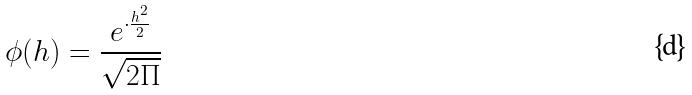<formula> <loc_0><loc_0><loc_500><loc_500>\phi ( h ) = \frac { e ^ { \cdot \frac { h ^ { 2 } } { 2 } } } { \sqrt { 2 \Pi } }</formula> 